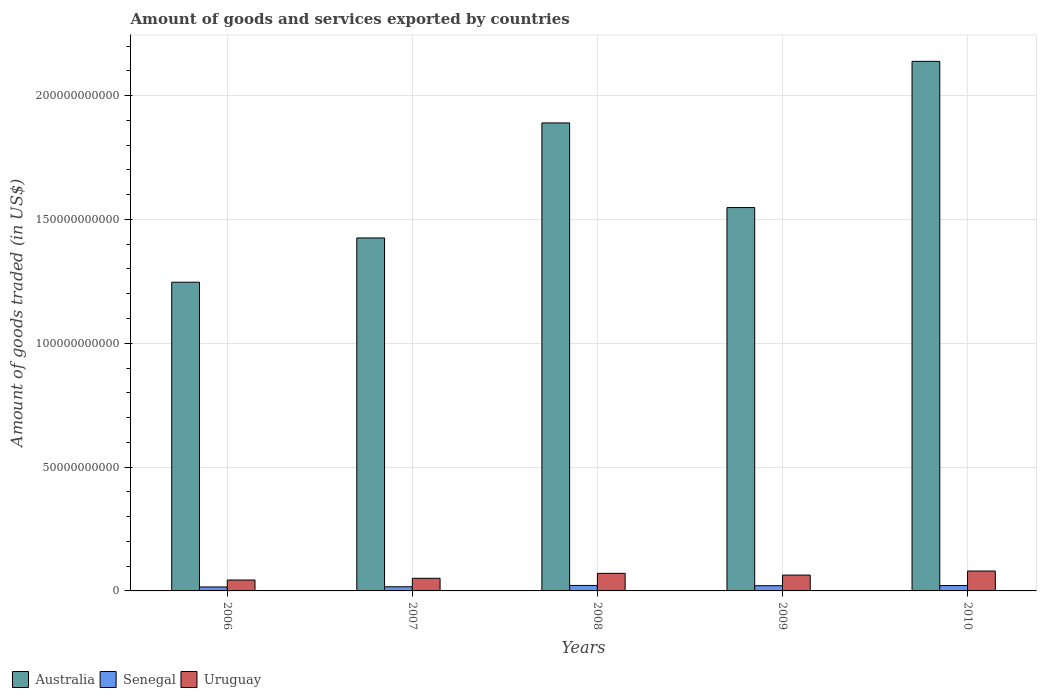Are the number of bars per tick equal to the number of legend labels?
Provide a succinct answer. Yes. How many bars are there on the 4th tick from the left?
Make the answer very short. 3. What is the total amount of goods and services exported in Australia in 2009?
Offer a very short reply. 1.55e+11. Across all years, what is the maximum total amount of goods and services exported in Australia?
Your answer should be compact. 2.14e+11. Across all years, what is the minimum total amount of goods and services exported in Senegal?
Provide a succinct answer. 1.60e+09. In which year was the total amount of goods and services exported in Uruguay maximum?
Your answer should be compact. 2010. In which year was the total amount of goods and services exported in Australia minimum?
Provide a succinct answer. 2006. What is the total total amount of goods and services exported in Uruguay in the graph?
Offer a very short reply. 3.10e+1. What is the difference between the total amount of goods and services exported in Senegal in 2006 and that in 2008?
Provide a succinct answer. -6.09e+08. What is the difference between the total amount of goods and services exported in Uruguay in 2008 and the total amount of goods and services exported in Australia in 2009?
Ensure brevity in your answer.  -1.48e+11. What is the average total amount of goods and services exported in Senegal per year?
Offer a terse response. 1.95e+09. In the year 2006, what is the difference between the total amount of goods and services exported in Senegal and total amount of goods and services exported in Australia?
Provide a short and direct response. -1.23e+11. What is the ratio of the total amount of goods and services exported in Uruguay in 2006 to that in 2009?
Your response must be concise. 0.69. Is the total amount of goods and services exported in Australia in 2006 less than that in 2010?
Your answer should be very brief. Yes. Is the difference between the total amount of goods and services exported in Senegal in 2006 and 2010 greater than the difference between the total amount of goods and services exported in Australia in 2006 and 2010?
Give a very brief answer. Yes. What is the difference between the highest and the second highest total amount of goods and services exported in Uruguay?
Your response must be concise. 9.35e+08. What is the difference between the highest and the lowest total amount of goods and services exported in Senegal?
Make the answer very short. 6.09e+08. In how many years, is the total amount of goods and services exported in Uruguay greater than the average total amount of goods and services exported in Uruguay taken over all years?
Ensure brevity in your answer.  3. What does the 1st bar from the left in 2010 represents?
Give a very brief answer. Australia. What does the 3rd bar from the right in 2010 represents?
Your response must be concise. Australia. Is it the case that in every year, the sum of the total amount of goods and services exported in Senegal and total amount of goods and services exported in Uruguay is greater than the total amount of goods and services exported in Australia?
Make the answer very short. No. How many bars are there?
Ensure brevity in your answer.  15. Are all the bars in the graph horizontal?
Give a very brief answer. No. Does the graph contain any zero values?
Provide a succinct answer. No. Does the graph contain grids?
Provide a succinct answer. Yes. How are the legend labels stacked?
Keep it short and to the point. Horizontal. What is the title of the graph?
Keep it short and to the point. Amount of goods and services exported by countries. What is the label or title of the Y-axis?
Offer a terse response. Amount of goods traded (in US$). What is the Amount of goods traded (in US$) in Australia in 2006?
Your answer should be compact. 1.25e+11. What is the Amount of goods traded (in US$) of Senegal in 2006?
Ensure brevity in your answer.  1.60e+09. What is the Amount of goods traded (in US$) in Uruguay in 2006?
Make the answer very short. 4.40e+09. What is the Amount of goods traded (in US$) in Australia in 2007?
Provide a short and direct response. 1.43e+11. What is the Amount of goods traded (in US$) of Senegal in 2007?
Offer a terse response. 1.68e+09. What is the Amount of goods traded (in US$) in Uruguay in 2007?
Provide a succinct answer. 5.10e+09. What is the Amount of goods traded (in US$) in Australia in 2008?
Give a very brief answer. 1.89e+11. What is the Amount of goods traded (in US$) of Senegal in 2008?
Make the answer very short. 2.21e+09. What is the Amount of goods traded (in US$) in Uruguay in 2008?
Your answer should be very brief. 7.10e+09. What is the Amount of goods traded (in US$) in Australia in 2009?
Your response must be concise. 1.55e+11. What is the Amount of goods traded (in US$) in Senegal in 2009?
Offer a terse response. 2.10e+09. What is the Amount of goods traded (in US$) of Uruguay in 2009?
Keep it short and to the point. 6.39e+09. What is the Amount of goods traded (in US$) in Australia in 2010?
Your answer should be compact. 2.14e+11. What is the Amount of goods traded (in US$) in Senegal in 2010?
Offer a very short reply. 2.16e+09. What is the Amount of goods traded (in US$) in Uruguay in 2010?
Your answer should be compact. 8.03e+09. Across all years, what is the maximum Amount of goods traded (in US$) of Australia?
Make the answer very short. 2.14e+11. Across all years, what is the maximum Amount of goods traded (in US$) of Senegal?
Your answer should be compact. 2.21e+09. Across all years, what is the maximum Amount of goods traded (in US$) in Uruguay?
Make the answer very short. 8.03e+09. Across all years, what is the minimum Amount of goods traded (in US$) in Australia?
Give a very brief answer. 1.25e+11. Across all years, what is the minimum Amount of goods traded (in US$) of Senegal?
Your response must be concise. 1.60e+09. Across all years, what is the minimum Amount of goods traded (in US$) in Uruguay?
Offer a terse response. 4.40e+09. What is the total Amount of goods traded (in US$) of Australia in the graph?
Provide a short and direct response. 8.25e+11. What is the total Amount of goods traded (in US$) in Senegal in the graph?
Provide a succinct answer. 9.75e+09. What is the total Amount of goods traded (in US$) in Uruguay in the graph?
Make the answer very short. 3.10e+1. What is the difference between the Amount of goods traded (in US$) in Australia in 2006 and that in 2007?
Offer a terse response. -1.79e+1. What is the difference between the Amount of goods traded (in US$) in Senegal in 2006 and that in 2007?
Keep it short and to the point. -8.17e+07. What is the difference between the Amount of goods traded (in US$) of Uruguay in 2006 and that in 2007?
Your response must be concise. -7.00e+08. What is the difference between the Amount of goods traded (in US$) of Australia in 2006 and that in 2008?
Provide a succinct answer. -6.43e+1. What is the difference between the Amount of goods traded (in US$) in Senegal in 2006 and that in 2008?
Make the answer very short. -6.09e+08. What is the difference between the Amount of goods traded (in US$) in Uruguay in 2006 and that in 2008?
Your answer should be compact. -2.70e+09. What is the difference between the Amount of goods traded (in US$) in Australia in 2006 and that in 2009?
Your response must be concise. -3.01e+1. What is the difference between the Amount of goods traded (in US$) in Senegal in 2006 and that in 2009?
Your answer should be compact. -4.97e+08. What is the difference between the Amount of goods traded (in US$) of Uruguay in 2006 and that in 2009?
Ensure brevity in your answer.  -1.99e+09. What is the difference between the Amount of goods traded (in US$) in Australia in 2006 and that in 2010?
Offer a very short reply. -8.92e+1. What is the difference between the Amount of goods traded (in US$) in Senegal in 2006 and that in 2010?
Provide a short and direct response. -5.64e+08. What is the difference between the Amount of goods traded (in US$) of Uruguay in 2006 and that in 2010?
Provide a short and direct response. -3.63e+09. What is the difference between the Amount of goods traded (in US$) in Australia in 2007 and that in 2008?
Your answer should be very brief. -4.64e+1. What is the difference between the Amount of goods traded (in US$) in Senegal in 2007 and that in 2008?
Your response must be concise. -5.27e+08. What is the difference between the Amount of goods traded (in US$) of Uruguay in 2007 and that in 2008?
Provide a short and direct response. -2.00e+09. What is the difference between the Amount of goods traded (in US$) in Australia in 2007 and that in 2009?
Provide a short and direct response. -1.23e+1. What is the difference between the Amount of goods traded (in US$) of Senegal in 2007 and that in 2009?
Offer a terse response. -4.15e+08. What is the difference between the Amount of goods traded (in US$) in Uruguay in 2007 and that in 2009?
Offer a very short reply. -1.29e+09. What is the difference between the Amount of goods traded (in US$) in Australia in 2007 and that in 2010?
Your answer should be very brief. -7.13e+1. What is the difference between the Amount of goods traded (in US$) in Senegal in 2007 and that in 2010?
Offer a very short reply. -4.83e+08. What is the difference between the Amount of goods traded (in US$) of Uruguay in 2007 and that in 2010?
Offer a very short reply. -2.93e+09. What is the difference between the Amount of goods traded (in US$) in Australia in 2008 and that in 2009?
Your answer should be very brief. 3.42e+1. What is the difference between the Amount of goods traded (in US$) of Senegal in 2008 and that in 2009?
Your answer should be very brief. 1.12e+08. What is the difference between the Amount of goods traded (in US$) of Uruguay in 2008 and that in 2009?
Ensure brevity in your answer.  7.04e+08. What is the difference between the Amount of goods traded (in US$) in Australia in 2008 and that in 2010?
Provide a succinct answer. -2.49e+1. What is the difference between the Amount of goods traded (in US$) of Senegal in 2008 and that in 2010?
Keep it short and to the point. 4.41e+07. What is the difference between the Amount of goods traded (in US$) of Uruguay in 2008 and that in 2010?
Make the answer very short. -9.35e+08. What is the difference between the Amount of goods traded (in US$) in Australia in 2009 and that in 2010?
Your answer should be very brief. -5.90e+1. What is the difference between the Amount of goods traded (in US$) of Senegal in 2009 and that in 2010?
Provide a succinct answer. -6.74e+07. What is the difference between the Amount of goods traded (in US$) in Uruguay in 2009 and that in 2010?
Your answer should be very brief. -1.64e+09. What is the difference between the Amount of goods traded (in US$) of Australia in 2006 and the Amount of goods traded (in US$) of Senegal in 2007?
Ensure brevity in your answer.  1.23e+11. What is the difference between the Amount of goods traded (in US$) in Australia in 2006 and the Amount of goods traded (in US$) in Uruguay in 2007?
Provide a short and direct response. 1.20e+11. What is the difference between the Amount of goods traded (in US$) of Senegal in 2006 and the Amount of goods traded (in US$) of Uruguay in 2007?
Your answer should be compact. -3.50e+09. What is the difference between the Amount of goods traded (in US$) in Australia in 2006 and the Amount of goods traded (in US$) in Senegal in 2008?
Offer a terse response. 1.22e+11. What is the difference between the Amount of goods traded (in US$) in Australia in 2006 and the Amount of goods traded (in US$) in Uruguay in 2008?
Offer a very short reply. 1.18e+11. What is the difference between the Amount of goods traded (in US$) in Senegal in 2006 and the Amount of goods traded (in US$) in Uruguay in 2008?
Provide a succinct answer. -5.50e+09. What is the difference between the Amount of goods traded (in US$) in Australia in 2006 and the Amount of goods traded (in US$) in Senegal in 2009?
Keep it short and to the point. 1.23e+11. What is the difference between the Amount of goods traded (in US$) in Australia in 2006 and the Amount of goods traded (in US$) in Uruguay in 2009?
Offer a terse response. 1.18e+11. What is the difference between the Amount of goods traded (in US$) in Senegal in 2006 and the Amount of goods traded (in US$) in Uruguay in 2009?
Give a very brief answer. -4.79e+09. What is the difference between the Amount of goods traded (in US$) in Australia in 2006 and the Amount of goods traded (in US$) in Senegal in 2010?
Your answer should be compact. 1.22e+11. What is the difference between the Amount of goods traded (in US$) of Australia in 2006 and the Amount of goods traded (in US$) of Uruguay in 2010?
Ensure brevity in your answer.  1.17e+11. What is the difference between the Amount of goods traded (in US$) in Senegal in 2006 and the Amount of goods traded (in US$) in Uruguay in 2010?
Offer a terse response. -6.43e+09. What is the difference between the Amount of goods traded (in US$) of Australia in 2007 and the Amount of goods traded (in US$) of Senegal in 2008?
Give a very brief answer. 1.40e+11. What is the difference between the Amount of goods traded (in US$) of Australia in 2007 and the Amount of goods traded (in US$) of Uruguay in 2008?
Your response must be concise. 1.35e+11. What is the difference between the Amount of goods traded (in US$) of Senegal in 2007 and the Amount of goods traded (in US$) of Uruguay in 2008?
Provide a short and direct response. -5.41e+09. What is the difference between the Amount of goods traded (in US$) in Australia in 2007 and the Amount of goods traded (in US$) in Senegal in 2009?
Offer a very short reply. 1.40e+11. What is the difference between the Amount of goods traded (in US$) in Australia in 2007 and the Amount of goods traded (in US$) in Uruguay in 2009?
Provide a succinct answer. 1.36e+11. What is the difference between the Amount of goods traded (in US$) in Senegal in 2007 and the Amount of goods traded (in US$) in Uruguay in 2009?
Offer a very short reply. -4.71e+09. What is the difference between the Amount of goods traded (in US$) of Australia in 2007 and the Amount of goods traded (in US$) of Senegal in 2010?
Your response must be concise. 1.40e+11. What is the difference between the Amount of goods traded (in US$) of Australia in 2007 and the Amount of goods traded (in US$) of Uruguay in 2010?
Offer a very short reply. 1.34e+11. What is the difference between the Amount of goods traded (in US$) of Senegal in 2007 and the Amount of goods traded (in US$) of Uruguay in 2010?
Your response must be concise. -6.35e+09. What is the difference between the Amount of goods traded (in US$) of Australia in 2008 and the Amount of goods traded (in US$) of Senegal in 2009?
Provide a short and direct response. 1.87e+11. What is the difference between the Amount of goods traded (in US$) of Australia in 2008 and the Amount of goods traded (in US$) of Uruguay in 2009?
Your answer should be compact. 1.83e+11. What is the difference between the Amount of goods traded (in US$) in Senegal in 2008 and the Amount of goods traded (in US$) in Uruguay in 2009?
Offer a terse response. -4.18e+09. What is the difference between the Amount of goods traded (in US$) in Australia in 2008 and the Amount of goods traded (in US$) in Senegal in 2010?
Your answer should be compact. 1.87e+11. What is the difference between the Amount of goods traded (in US$) of Australia in 2008 and the Amount of goods traded (in US$) of Uruguay in 2010?
Make the answer very short. 1.81e+11. What is the difference between the Amount of goods traded (in US$) in Senegal in 2008 and the Amount of goods traded (in US$) in Uruguay in 2010?
Provide a succinct answer. -5.82e+09. What is the difference between the Amount of goods traded (in US$) of Australia in 2009 and the Amount of goods traded (in US$) of Senegal in 2010?
Your response must be concise. 1.53e+11. What is the difference between the Amount of goods traded (in US$) in Australia in 2009 and the Amount of goods traded (in US$) in Uruguay in 2010?
Keep it short and to the point. 1.47e+11. What is the difference between the Amount of goods traded (in US$) of Senegal in 2009 and the Amount of goods traded (in US$) of Uruguay in 2010?
Make the answer very short. -5.93e+09. What is the average Amount of goods traded (in US$) of Australia per year?
Offer a very short reply. 1.65e+11. What is the average Amount of goods traded (in US$) in Senegal per year?
Provide a short and direct response. 1.95e+09. What is the average Amount of goods traded (in US$) in Uruguay per year?
Your answer should be very brief. 6.20e+09. In the year 2006, what is the difference between the Amount of goods traded (in US$) of Australia and Amount of goods traded (in US$) of Senegal?
Provide a short and direct response. 1.23e+11. In the year 2006, what is the difference between the Amount of goods traded (in US$) in Australia and Amount of goods traded (in US$) in Uruguay?
Your answer should be very brief. 1.20e+11. In the year 2006, what is the difference between the Amount of goods traded (in US$) of Senegal and Amount of goods traded (in US$) of Uruguay?
Offer a very short reply. -2.80e+09. In the year 2007, what is the difference between the Amount of goods traded (in US$) in Australia and Amount of goods traded (in US$) in Senegal?
Ensure brevity in your answer.  1.41e+11. In the year 2007, what is the difference between the Amount of goods traded (in US$) of Australia and Amount of goods traded (in US$) of Uruguay?
Ensure brevity in your answer.  1.37e+11. In the year 2007, what is the difference between the Amount of goods traded (in US$) in Senegal and Amount of goods traded (in US$) in Uruguay?
Make the answer very short. -3.42e+09. In the year 2008, what is the difference between the Amount of goods traded (in US$) in Australia and Amount of goods traded (in US$) in Senegal?
Make the answer very short. 1.87e+11. In the year 2008, what is the difference between the Amount of goods traded (in US$) in Australia and Amount of goods traded (in US$) in Uruguay?
Your answer should be very brief. 1.82e+11. In the year 2008, what is the difference between the Amount of goods traded (in US$) of Senegal and Amount of goods traded (in US$) of Uruguay?
Offer a terse response. -4.89e+09. In the year 2009, what is the difference between the Amount of goods traded (in US$) of Australia and Amount of goods traded (in US$) of Senegal?
Provide a succinct answer. 1.53e+11. In the year 2009, what is the difference between the Amount of goods traded (in US$) in Australia and Amount of goods traded (in US$) in Uruguay?
Your answer should be compact. 1.48e+11. In the year 2009, what is the difference between the Amount of goods traded (in US$) in Senegal and Amount of goods traded (in US$) in Uruguay?
Provide a short and direct response. -4.29e+09. In the year 2010, what is the difference between the Amount of goods traded (in US$) of Australia and Amount of goods traded (in US$) of Senegal?
Offer a very short reply. 2.12e+11. In the year 2010, what is the difference between the Amount of goods traded (in US$) in Australia and Amount of goods traded (in US$) in Uruguay?
Offer a terse response. 2.06e+11. In the year 2010, what is the difference between the Amount of goods traded (in US$) in Senegal and Amount of goods traded (in US$) in Uruguay?
Keep it short and to the point. -5.87e+09. What is the ratio of the Amount of goods traded (in US$) in Australia in 2006 to that in 2007?
Give a very brief answer. 0.87. What is the ratio of the Amount of goods traded (in US$) of Senegal in 2006 to that in 2007?
Provide a short and direct response. 0.95. What is the ratio of the Amount of goods traded (in US$) in Uruguay in 2006 to that in 2007?
Give a very brief answer. 0.86. What is the ratio of the Amount of goods traded (in US$) in Australia in 2006 to that in 2008?
Ensure brevity in your answer.  0.66. What is the ratio of the Amount of goods traded (in US$) of Senegal in 2006 to that in 2008?
Offer a very short reply. 0.72. What is the ratio of the Amount of goods traded (in US$) of Uruguay in 2006 to that in 2008?
Give a very brief answer. 0.62. What is the ratio of the Amount of goods traded (in US$) of Australia in 2006 to that in 2009?
Keep it short and to the point. 0.81. What is the ratio of the Amount of goods traded (in US$) of Senegal in 2006 to that in 2009?
Your answer should be very brief. 0.76. What is the ratio of the Amount of goods traded (in US$) of Uruguay in 2006 to that in 2009?
Your response must be concise. 0.69. What is the ratio of the Amount of goods traded (in US$) of Australia in 2006 to that in 2010?
Offer a very short reply. 0.58. What is the ratio of the Amount of goods traded (in US$) in Senegal in 2006 to that in 2010?
Your answer should be very brief. 0.74. What is the ratio of the Amount of goods traded (in US$) of Uruguay in 2006 to that in 2010?
Your answer should be compact. 0.55. What is the ratio of the Amount of goods traded (in US$) in Australia in 2007 to that in 2008?
Offer a very short reply. 0.75. What is the ratio of the Amount of goods traded (in US$) of Senegal in 2007 to that in 2008?
Provide a short and direct response. 0.76. What is the ratio of the Amount of goods traded (in US$) of Uruguay in 2007 to that in 2008?
Your answer should be very brief. 0.72. What is the ratio of the Amount of goods traded (in US$) in Australia in 2007 to that in 2009?
Give a very brief answer. 0.92. What is the ratio of the Amount of goods traded (in US$) of Senegal in 2007 to that in 2009?
Provide a short and direct response. 0.8. What is the ratio of the Amount of goods traded (in US$) in Uruguay in 2007 to that in 2009?
Your response must be concise. 0.8. What is the ratio of the Amount of goods traded (in US$) in Australia in 2007 to that in 2010?
Ensure brevity in your answer.  0.67. What is the ratio of the Amount of goods traded (in US$) of Senegal in 2007 to that in 2010?
Ensure brevity in your answer.  0.78. What is the ratio of the Amount of goods traded (in US$) of Uruguay in 2007 to that in 2010?
Keep it short and to the point. 0.64. What is the ratio of the Amount of goods traded (in US$) of Australia in 2008 to that in 2009?
Keep it short and to the point. 1.22. What is the ratio of the Amount of goods traded (in US$) of Senegal in 2008 to that in 2009?
Your answer should be very brief. 1.05. What is the ratio of the Amount of goods traded (in US$) in Uruguay in 2008 to that in 2009?
Provide a succinct answer. 1.11. What is the ratio of the Amount of goods traded (in US$) in Australia in 2008 to that in 2010?
Keep it short and to the point. 0.88. What is the ratio of the Amount of goods traded (in US$) of Senegal in 2008 to that in 2010?
Make the answer very short. 1.02. What is the ratio of the Amount of goods traded (in US$) in Uruguay in 2008 to that in 2010?
Provide a succinct answer. 0.88. What is the ratio of the Amount of goods traded (in US$) in Australia in 2009 to that in 2010?
Offer a very short reply. 0.72. What is the ratio of the Amount of goods traded (in US$) of Senegal in 2009 to that in 2010?
Make the answer very short. 0.97. What is the ratio of the Amount of goods traded (in US$) of Uruguay in 2009 to that in 2010?
Provide a short and direct response. 0.8. What is the difference between the highest and the second highest Amount of goods traded (in US$) in Australia?
Offer a terse response. 2.49e+1. What is the difference between the highest and the second highest Amount of goods traded (in US$) of Senegal?
Offer a terse response. 4.41e+07. What is the difference between the highest and the second highest Amount of goods traded (in US$) of Uruguay?
Offer a terse response. 9.35e+08. What is the difference between the highest and the lowest Amount of goods traded (in US$) of Australia?
Your answer should be compact. 8.92e+1. What is the difference between the highest and the lowest Amount of goods traded (in US$) of Senegal?
Your answer should be compact. 6.09e+08. What is the difference between the highest and the lowest Amount of goods traded (in US$) in Uruguay?
Your answer should be compact. 3.63e+09. 